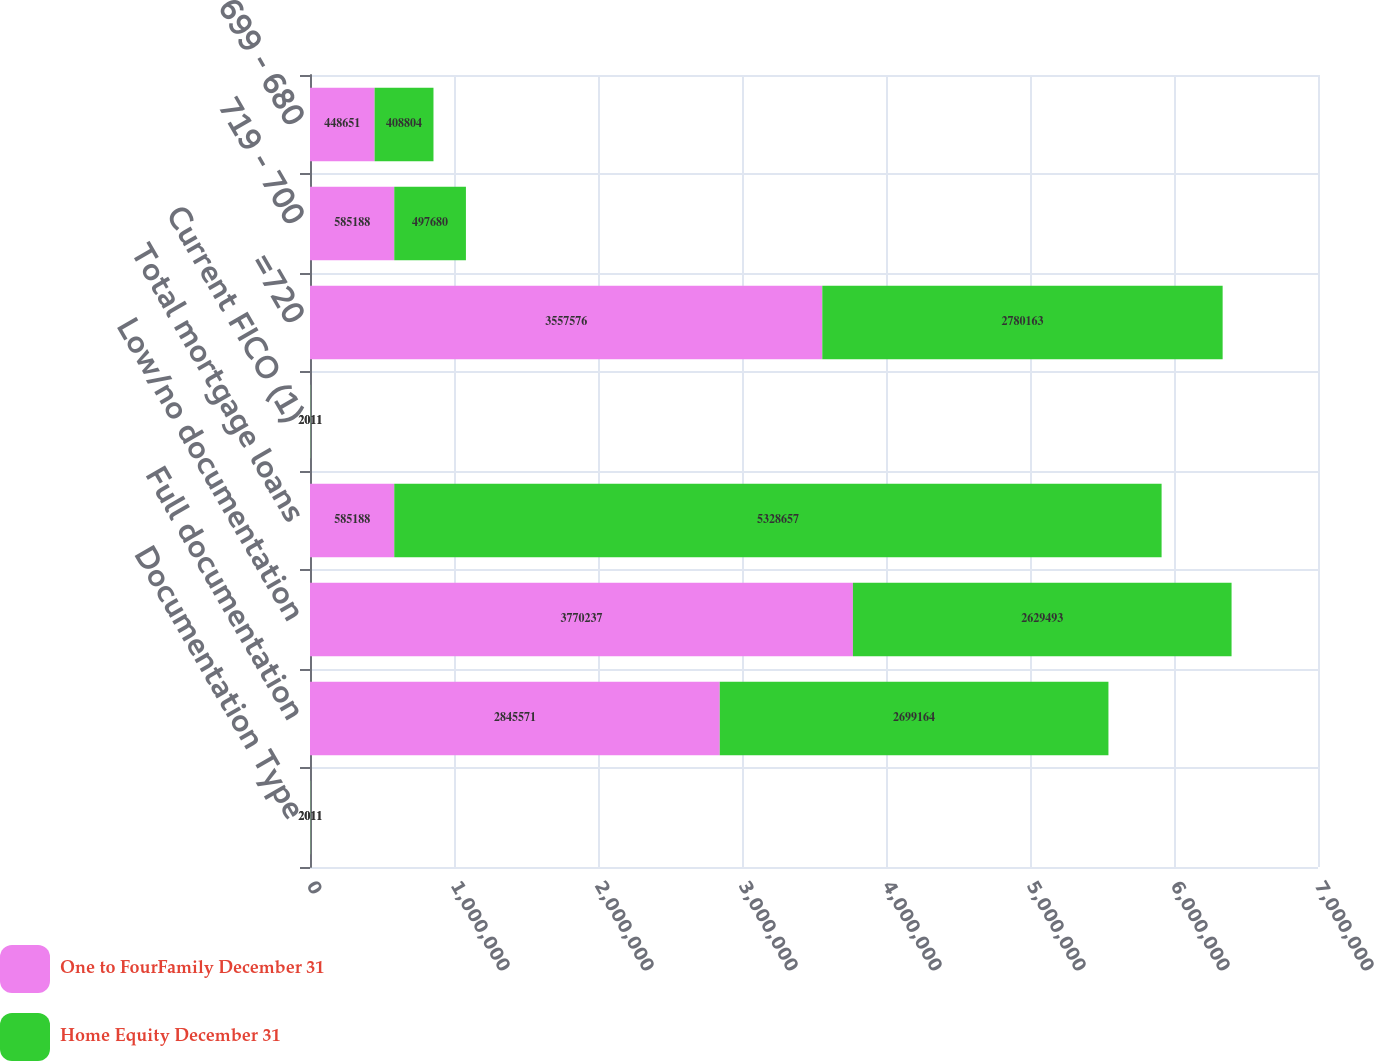Convert chart to OTSL. <chart><loc_0><loc_0><loc_500><loc_500><stacked_bar_chart><ecel><fcel>Documentation Type<fcel>Full documentation<fcel>Low/no documentation<fcel>Total mortgage loans<fcel>Current FICO (1)<fcel>=720<fcel>719 - 700<fcel>699 - 680<nl><fcel>One to FourFamily December 31<fcel>2011<fcel>2.84557e+06<fcel>3.77024e+06<fcel>585188<fcel>2011<fcel>3.55758e+06<fcel>585188<fcel>448651<nl><fcel>Home Equity December 31<fcel>2011<fcel>2.69916e+06<fcel>2.62949e+06<fcel>5.32866e+06<fcel>2011<fcel>2.78016e+06<fcel>497680<fcel>408804<nl></chart> 